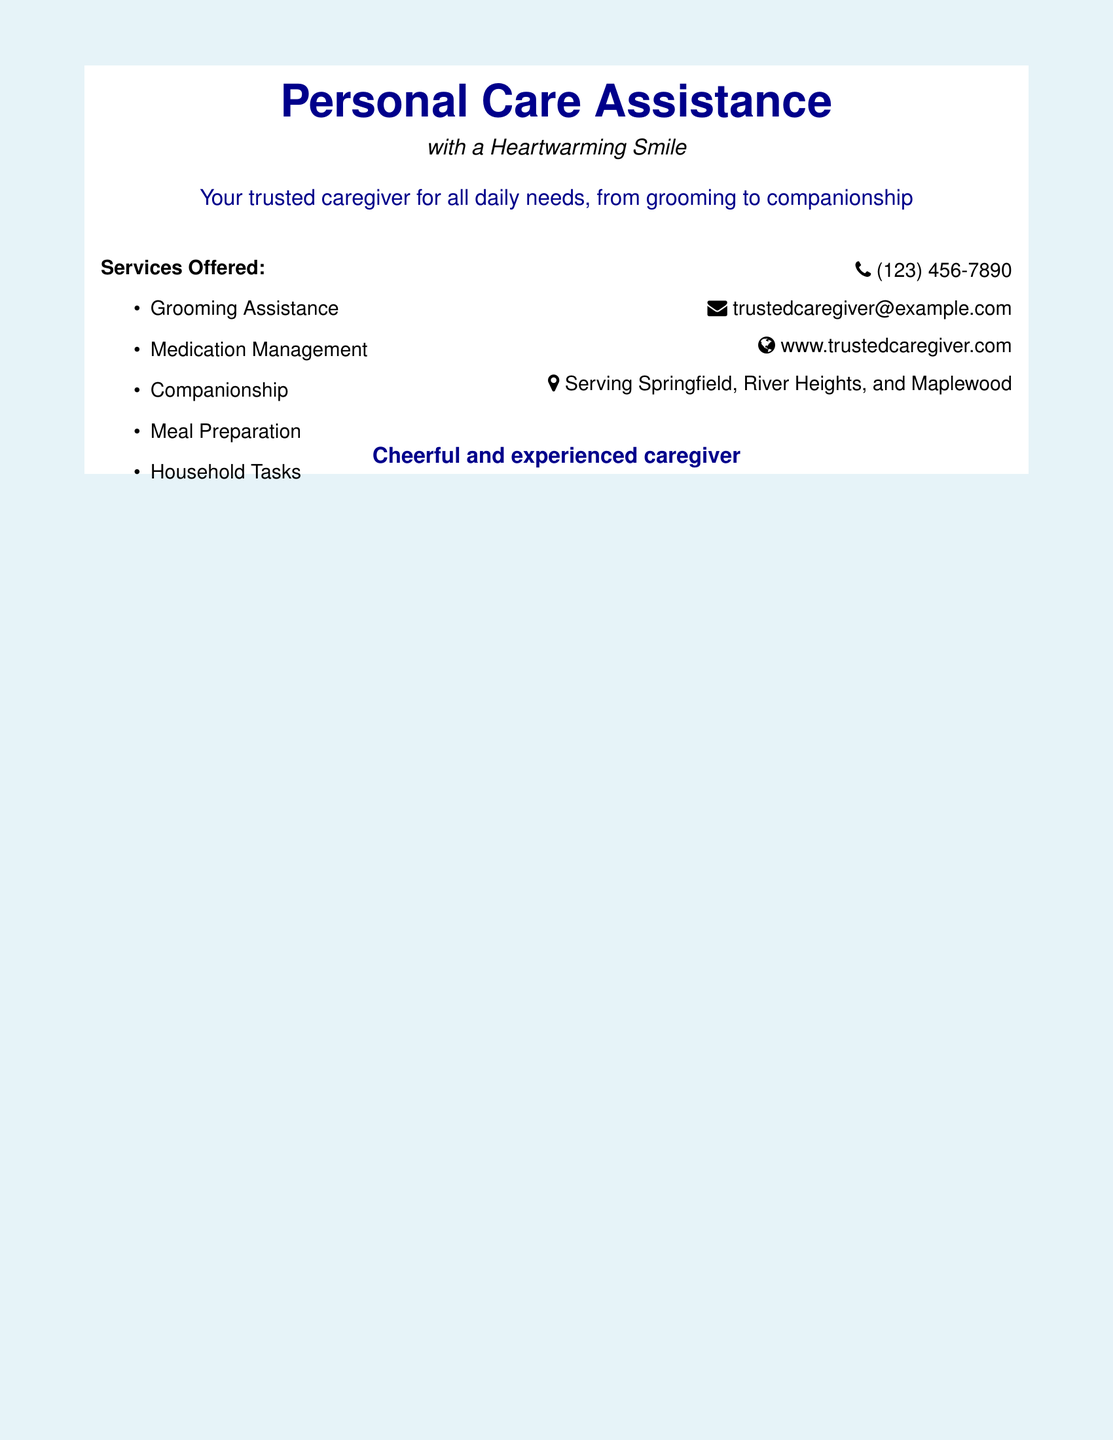What is the main service offered? The main service offered is personal care assistance as described in the document's title and subtitle.
Answer: Personal Care Assistance What are the contact details provided? The contact details include a phone number, email address, and website as listed in the document.
Answer: (123) 456-7890, trustedcaregiver@example.com, www.trustedcaregiver.com Which areas are served by the caregiver? The document states the specific locations where the caregiver provides services.
Answer: Springfield, River Heights, and Maplewood How many services are listed? The document contains a list of services offered, which needs to be counted for this answer.
Answer: Five What type of caregiver is emphasized in the document? The document highlights the caregiver's attitude and experience as described in the text.
Answer: Cheerful and experienced Which service involves preparing meals? The services listed in the document help identify the specific service that includes meal preparation.
Answer: Meal Preparation What is the slogan of the caregiver service? The slogan reflects the warm approach to caregiving found in the document.
Answer: with a Heartwarming Smile 